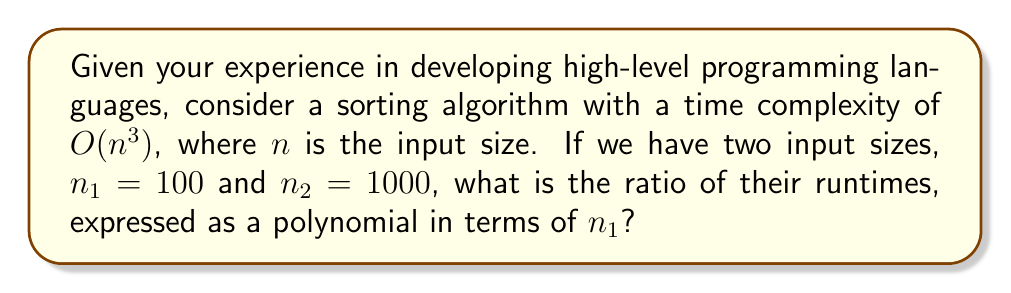What is the answer to this math problem? Let's approach this step-by-step:

1) The time complexity of the algorithm is $O(n^3)$. This means the runtime is proportional to $n^3$.

2) For $n_1 = 100$, the runtime is proportional to $100^3 = 1,000,000$.

3) For $n_2 = 1000$, the runtime is proportional to $1000^3 = 1,000,000,000$.

4) To find the ratio, we divide the runtime for $n_2$ by the runtime for $n_1$:

   $$\frac{1,000,000,000}{1,000,000} = 1000$$

5) Now, we need to express this ratio in terms of $n_1$. We know that $n_2 = 1000$ and $n_1 = 100$.

6) We can express 1000 in terms of 100 as:

   $$1000 = 10 \times 100 = 10n_1$$

7) Therefore, the ratio can be expressed as:

   $$(10n_1)^3 = 1000n_1^3$$

This polynomial expression in terms of $n_1$ represents the ratio of runtimes.
Answer: $1000n_1^3$ 